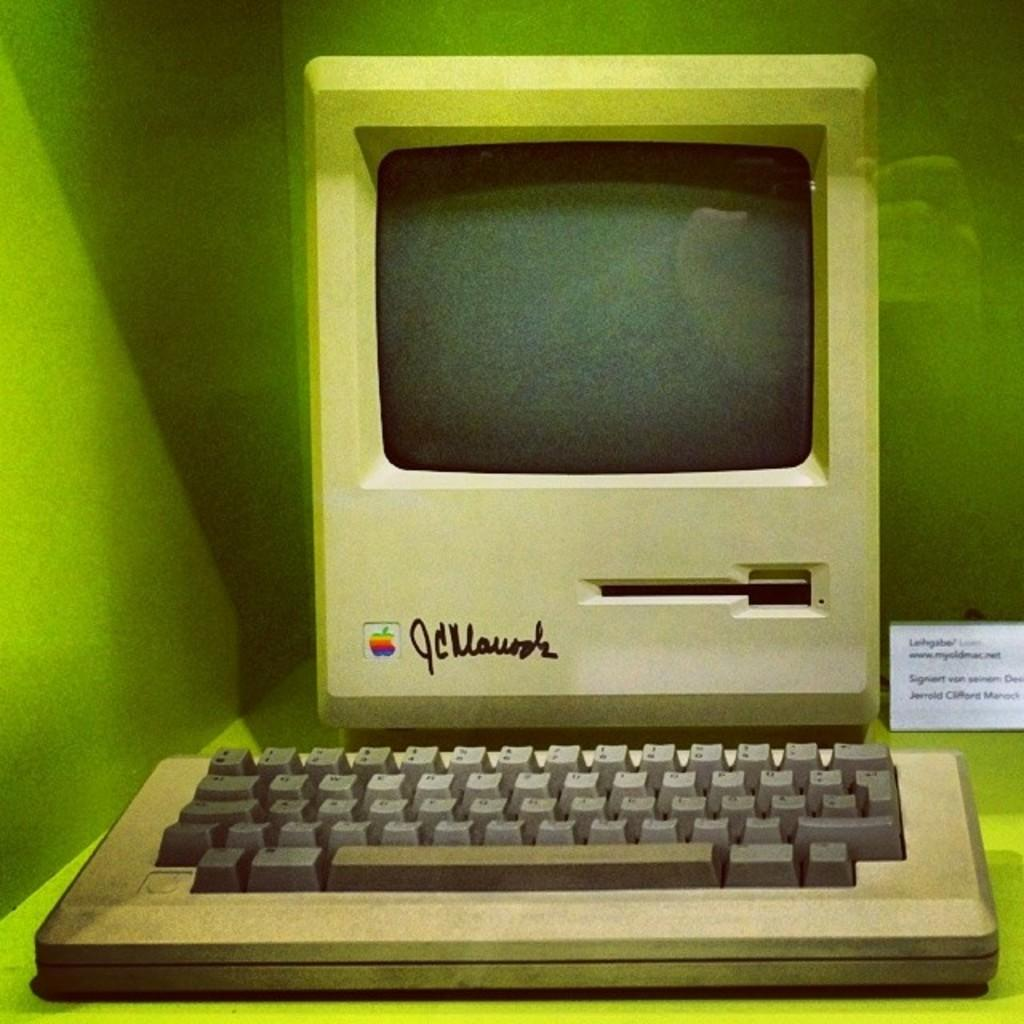<image>
Describe the image concisely. An old apple computer is signed by JC Manock. 